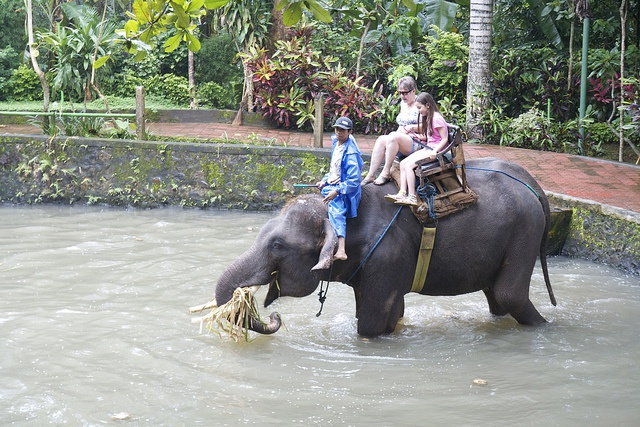Describe the objects in this image and their specific colors. I can see elephant in darkgray, black, and gray tones, people in darkgray, lavender, and lightblue tones, bench in darkgray, gray, and black tones, people in darkgray, lavender, pink, and gray tones, and people in darkgray, lavender, gray, and pink tones in this image. 